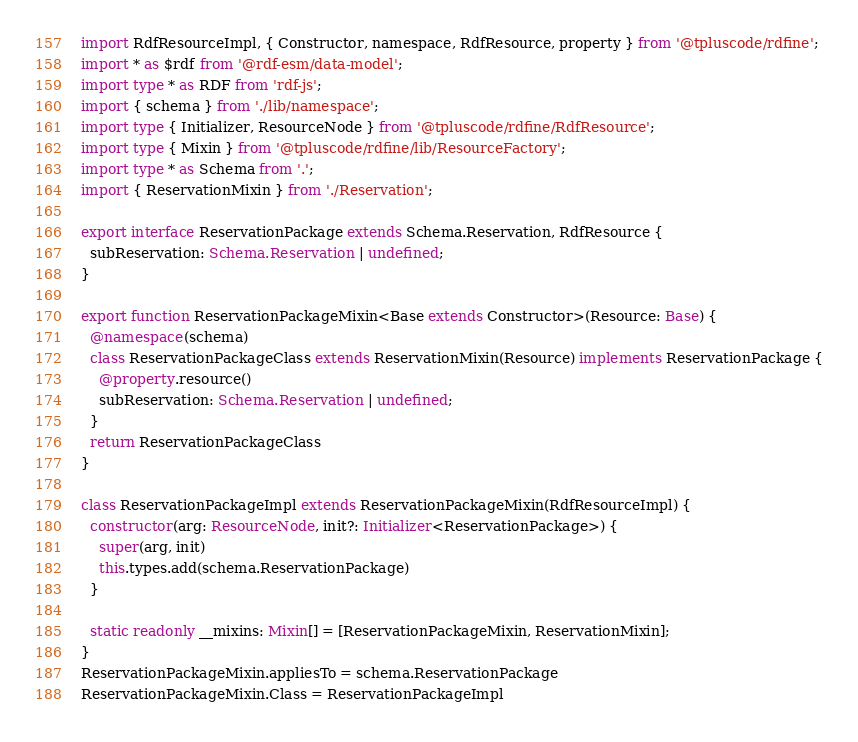<code> <loc_0><loc_0><loc_500><loc_500><_TypeScript_>import RdfResourceImpl, { Constructor, namespace, RdfResource, property } from '@tpluscode/rdfine';
import * as $rdf from '@rdf-esm/data-model';
import type * as RDF from 'rdf-js';
import { schema } from './lib/namespace';
import type { Initializer, ResourceNode } from '@tpluscode/rdfine/RdfResource';
import type { Mixin } from '@tpluscode/rdfine/lib/ResourceFactory';
import type * as Schema from '.';
import { ReservationMixin } from './Reservation';

export interface ReservationPackage extends Schema.Reservation, RdfResource {
  subReservation: Schema.Reservation | undefined;
}

export function ReservationPackageMixin<Base extends Constructor>(Resource: Base) {
  @namespace(schema)
  class ReservationPackageClass extends ReservationMixin(Resource) implements ReservationPackage {
    @property.resource()
    subReservation: Schema.Reservation | undefined;
  }
  return ReservationPackageClass
}

class ReservationPackageImpl extends ReservationPackageMixin(RdfResourceImpl) {
  constructor(arg: ResourceNode, init?: Initializer<ReservationPackage>) {
    super(arg, init)
    this.types.add(schema.ReservationPackage)
  }

  static readonly __mixins: Mixin[] = [ReservationPackageMixin, ReservationMixin];
}
ReservationPackageMixin.appliesTo = schema.ReservationPackage
ReservationPackageMixin.Class = ReservationPackageImpl
</code> 